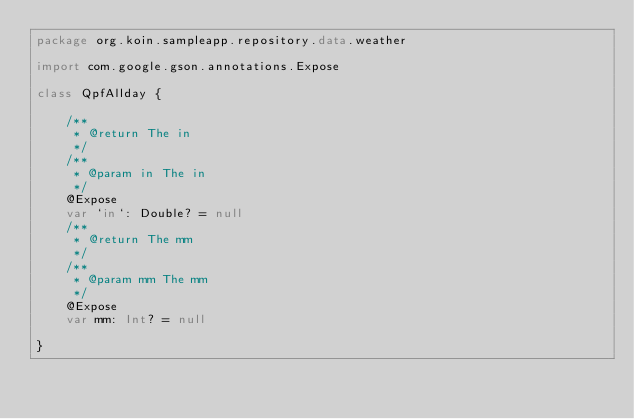Convert code to text. <code><loc_0><loc_0><loc_500><loc_500><_Kotlin_>package org.koin.sampleapp.repository.data.weather

import com.google.gson.annotations.Expose

class QpfAllday {

    /**
     * @return The in
     */
    /**
     * @param in The in
     */
    @Expose
    var `in`: Double? = null
    /**
     * @return The mm
     */
    /**
     * @param mm The mm
     */
    @Expose
    var mm: Int? = null

}
</code> 